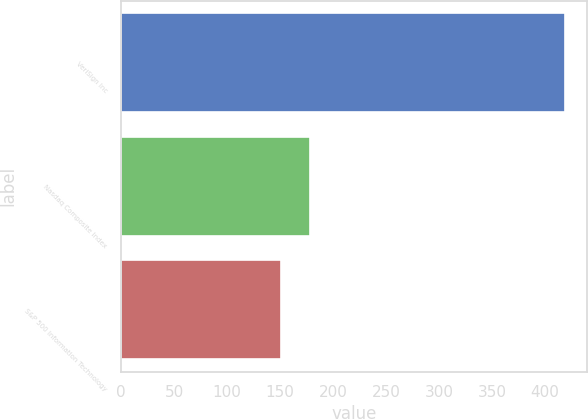Convert chart to OTSL. <chart><loc_0><loc_0><loc_500><loc_500><bar_chart><fcel>VeriSign Inc<fcel>Nasdaq Composite Index<fcel>S&P 500 Information Technology<nl><fcel>419<fcel>177.8<fcel>151<nl></chart> 